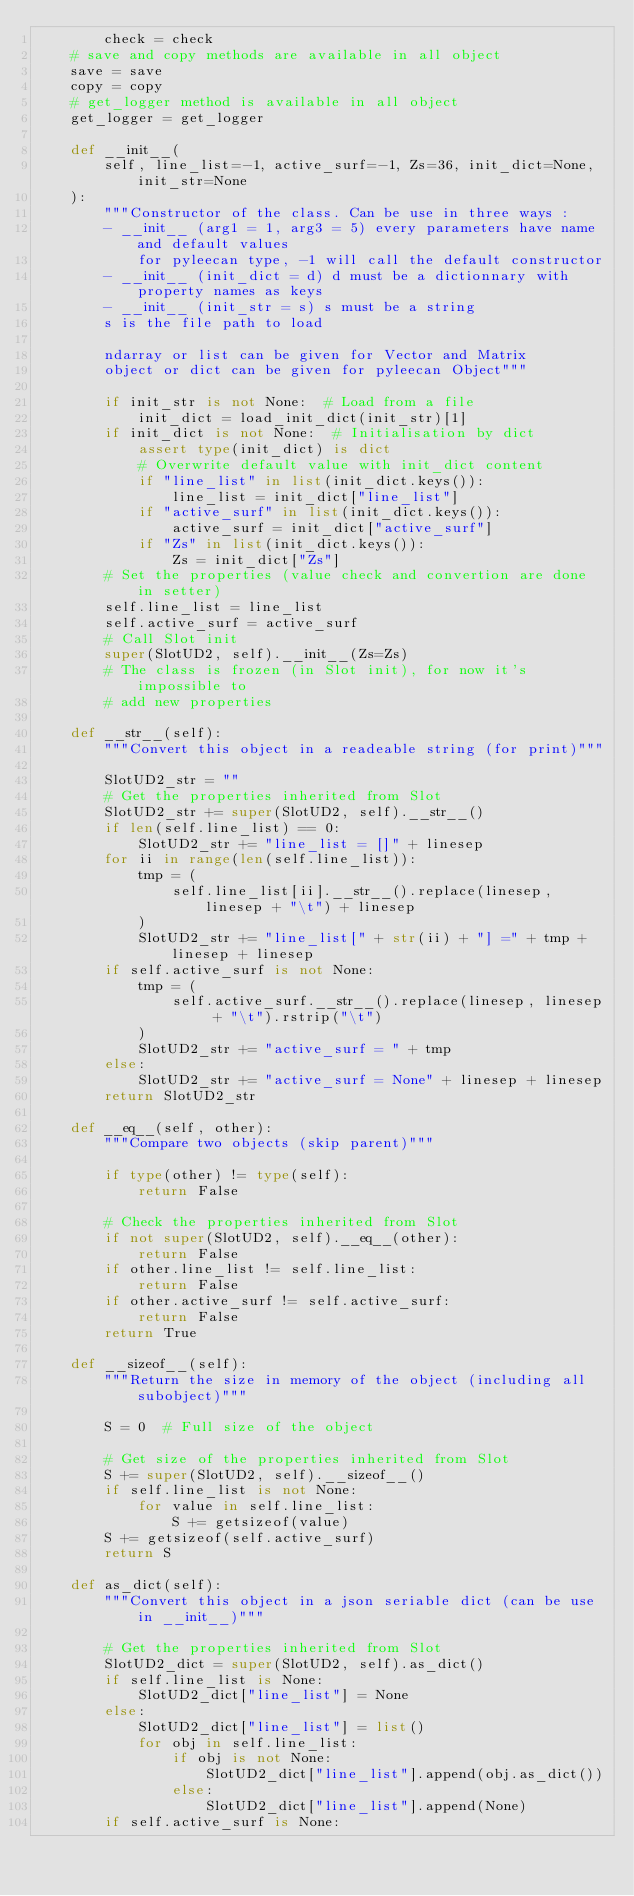<code> <loc_0><loc_0><loc_500><loc_500><_Python_>        check = check
    # save and copy methods are available in all object
    save = save
    copy = copy
    # get_logger method is available in all object
    get_logger = get_logger

    def __init__(
        self, line_list=-1, active_surf=-1, Zs=36, init_dict=None, init_str=None
    ):
        """Constructor of the class. Can be use in three ways :
        - __init__ (arg1 = 1, arg3 = 5) every parameters have name and default values
            for pyleecan type, -1 will call the default constructor
        - __init__ (init_dict = d) d must be a dictionnary with property names as keys
        - __init__ (init_str = s) s must be a string
        s is the file path to load

        ndarray or list can be given for Vector and Matrix
        object or dict can be given for pyleecan Object"""

        if init_str is not None:  # Load from a file
            init_dict = load_init_dict(init_str)[1]
        if init_dict is not None:  # Initialisation by dict
            assert type(init_dict) is dict
            # Overwrite default value with init_dict content
            if "line_list" in list(init_dict.keys()):
                line_list = init_dict["line_list"]
            if "active_surf" in list(init_dict.keys()):
                active_surf = init_dict["active_surf"]
            if "Zs" in list(init_dict.keys()):
                Zs = init_dict["Zs"]
        # Set the properties (value check and convertion are done in setter)
        self.line_list = line_list
        self.active_surf = active_surf
        # Call Slot init
        super(SlotUD2, self).__init__(Zs=Zs)
        # The class is frozen (in Slot init), for now it's impossible to
        # add new properties

    def __str__(self):
        """Convert this object in a readeable string (for print)"""

        SlotUD2_str = ""
        # Get the properties inherited from Slot
        SlotUD2_str += super(SlotUD2, self).__str__()
        if len(self.line_list) == 0:
            SlotUD2_str += "line_list = []" + linesep
        for ii in range(len(self.line_list)):
            tmp = (
                self.line_list[ii].__str__().replace(linesep, linesep + "\t") + linesep
            )
            SlotUD2_str += "line_list[" + str(ii) + "] =" + tmp + linesep + linesep
        if self.active_surf is not None:
            tmp = (
                self.active_surf.__str__().replace(linesep, linesep + "\t").rstrip("\t")
            )
            SlotUD2_str += "active_surf = " + tmp
        else:
            SlotUD2_str += "active_surf = None" + linesep + linesep
        return SlotUD2_str

    def __eq__(self, other):
        """Compare two objects (skip parent)"""

        if type(other) != type(self):
            return False

        # Check the properties inherited from Slot
        if not super(SlotUD2, self).__eq__(other):
            return False
        if other.line_list != self.line_list:
            return False
        if other.active_surf != self.active_surf:
            return False
        return True

    def __sizeof__(self):
        """Return the size in memory of the object (including all subobject)"""

        S = 0  # Full size of the object

        # Get size of the properties inherited from Slot
        S += super(SlotUD2, self).__sizeof__()
        if self.line_list is not None:
            for value in self.line_list:
                S += getsizeof(value)
        S += getsizeof(self.active_surf)
        return S

    def as_dict(self):
        """Convert this object in a json seriable dict (can be use in __init__)"""

        # Get the properties inherited from Slot
        SlotUD2_dict = super(SlotUD2, self).as_dict()
        if self.line_list is None:
            SlotUD2_dict["line_list"] = None
        else:
            SlotUD2_dict["line_list"] = list()
            for obj in self.line_list:
                if obj is not None:
                    SlotUD2_dict["line_list"].append(obj.as_dict())
                else:
                    SlotUD2_dict["line_list"].append(None)
        if self.active_surf is None:</code> 